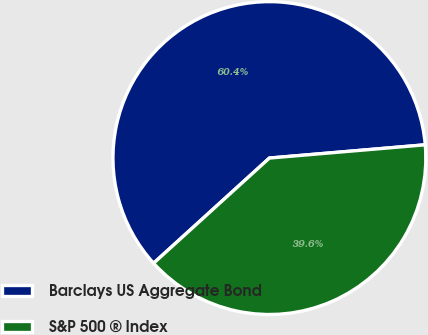Convert chart to OTSL. <chart><loc_0><loc_0><loc_500><loc_500><pie_chart><fcel>Barclays US Aggregate Bond<fcel>S&P 500 ® Index<nl><fcel>60.38%<fcel>39.62%<nl></chart> 